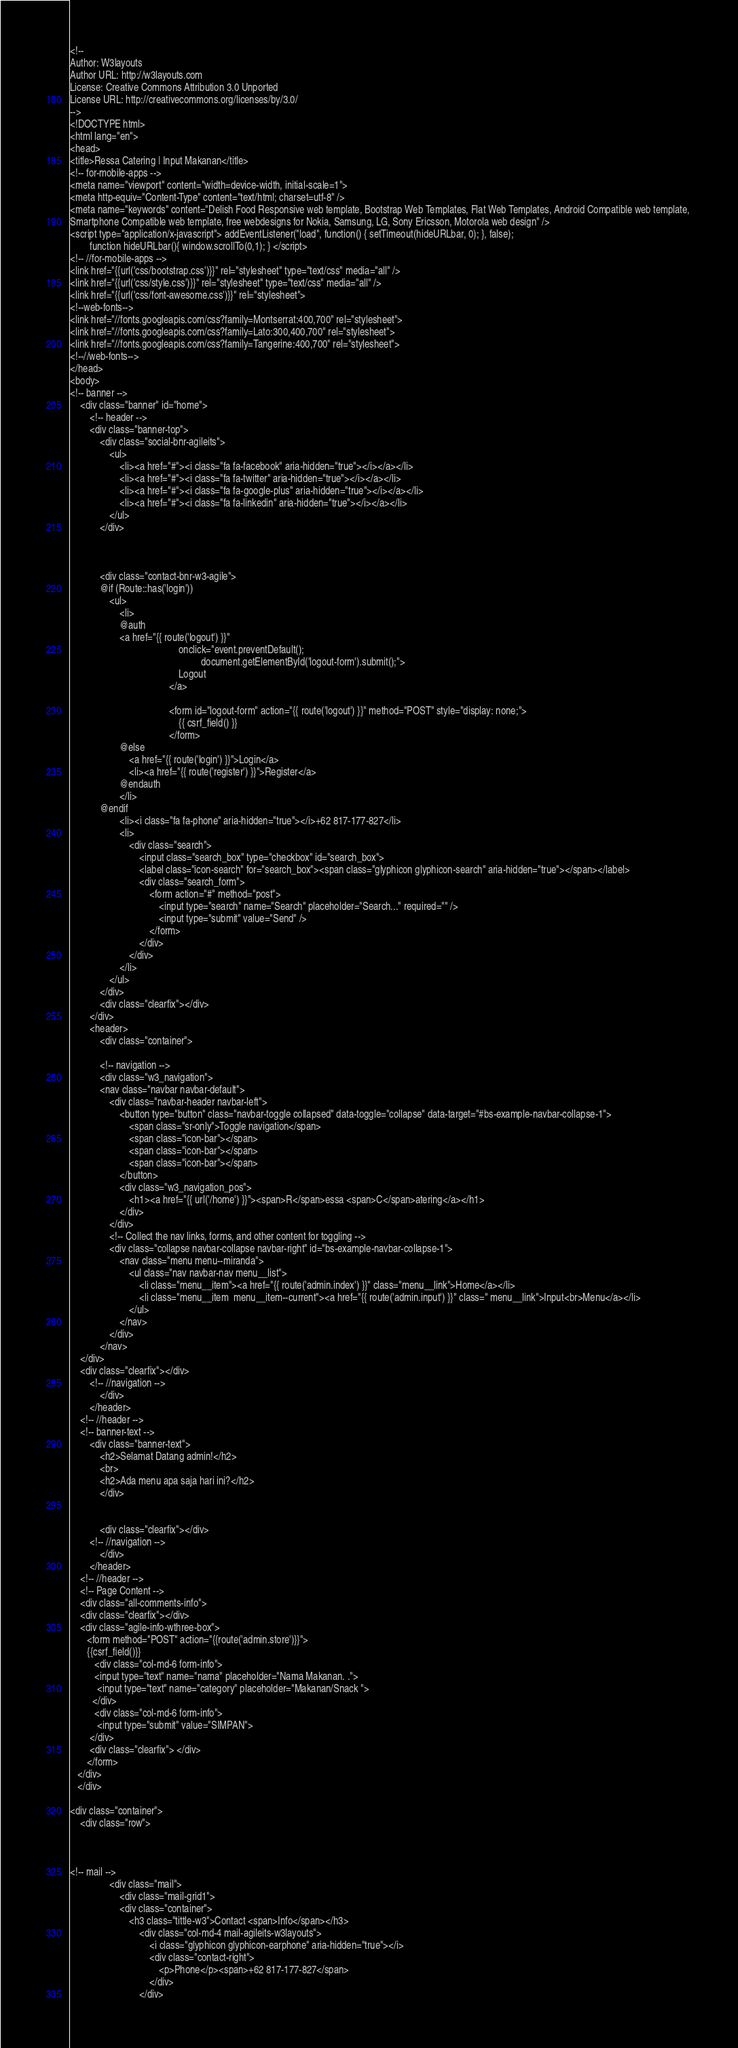Convert code to text. <code><loc_0><loc_0><loc_500><loc_500><_PHP_><!--
Author: W3layouts
Author URL: http://w3layouts.com
License: Creative Commons Attribution 3.0 Unported
License URL: http://creativecommons.org/licenses/by/3.0/
-->
<!DOCTYPE html>
<html lang="en">
<head>
<title>Ressa Catering | Input Makanan</title>
<!-- for-mobile-apps -->
<meta name="viewport" content="width=device-width, initial-scale=1">
<meta http-equiv="Content-Type" content="text/html; charset=utf-8" />
<meta name="keywords" content="Delish Food Responsive web template, Bootstrap Web Templates, Flat Web Templates, Android Compatible web template, 
Smartphone Compatible web template, free webdesigns for Nokia, Samsung, LG, Sony Ericsson, Motorola web design" />
<script type="application/x-javascript"> addEventListener("load", function() { setTimeout(hideURLbar, 0); }, false);
		function hideURLbar(){ window.scrollTo(0,1); } </script>
<!-- //for-mobile-apps -->
<link href="{{url('css/bootstrap.css')}}" rel="stylesheet" type="text/css" media="all" />
<link href="{{url('css/style.css')}}" rel="stylesheet" type="text/css" media="all" />
<link href="{{url('css/font-awesome.css')}}" rel="stylesheet"> 
<!--web-fonts-->
<link href="//fonts.googleapis.com/css?family=Montserrat:400,700" rel="stylesheet">
<link href="//fonts.googleapis.com/css?family=Lato:300,400,700" rel="stylesheet">
<link href="//fonts.googleapis.com/css?family=Tangerine:400,700" rel="stylesheet">
<!--//web-fonts-->
</head>
<body>
<!-- banner -->
	<div class="banner" id="home">
		<!-- header -->
		<div class="banner-top">
			<div class="social-bnr-agileits">
				<ul>
					<li><a href="#"><i class="fa fa-facebook" aria-hidden="true"></i></a></li>
					<li><a href="#"><i class="fa fa-twitter" aria-hidden="true"></i></a></li>
					<li><a href="#"><i class="fa fa-google-plus" aria-hidden="true"></i></a></li>
					<li><a href="#"><i class="fa fa-linkedin" aria-hidden="true"></i></a></li>					
				</ul>
			</div>

			 
			
			<div class="contact-bnr-w3-agile">
			@if (Route::has('login'))
				<ul>
					<li>
					@auth
					<a href="{{ route('logout') }}"
                                            onclick="event.preventDefault();
                                                     document.getElementById('logout-form').submit();">
                                            Logout
                                        </a>

                                        <form id="logout-form" action="{{ route('logout') }}" method="POST" style="display: none;">
                                            {{ csrf_field() }}
                                        </form>
                    @else
                        <a href="{{ route('login') }}">Login</a>
                        <li><a href="{{ route('register') }}">Register</a>
                    @endauth
					</li>
			@endif
					<li><i class="fa fa-phone" aria-hidden="true"></i>+62 817-177-827</li>	
					<li>
						<div class="search">
							<input class="search_box" type="checkbox" id="search_box">
							<label class="icon-search" for="search_box"><span class="glyphicon glyphicon-search" aria-hidden="true"></span></label>
							<div class="search_form">
								<form action="#" method="post">
									<input type="search" name="Search" placeholder="Search..." required="" />
									<input type="submit" value="Send" />
								</form>
							</div>
						</div>
					</li>
				</ul>
			</div>
			<div class="clearfix"></div>
		</div>
		<header>
			<div class="container">

			<!-- navigation -->
			<div class="w3_navigation">
			<nav class="navbar navbar-default">
				<div class="navbar-header navbar-left">
					<button type="button" class="navbar-toggle collapsed" data-toggle="collapse" data-target="#bs-example-navbar-collapse-1">
						<span class="sr-only">Toggle navigation</span>
						<span class="icon-bar"></span>
						<span class="icon-bar"></span>
						<span class="icon-bar"></span>
					</button>
					<div class="w3_navigation_pos">
						<h1><a href="{{ url('/home') }}"><span>R</span>essa <span>C</span>atering</a></h1>
					</div>
				</div>
				<!-- Collect the nav links, forms, and other content for toggling -->
				<div class="collapse navbar-collapse navbar-right" id="bs-example-navbar-collapse-1">
					<nav class="menu menu--miranda">
						<ul class="nav navbar-nav menu__list">
							<li class="menu__item"><a href="{{ route('admin.index') }}" class="menu__link">Home</a></li>
							<li class="menu__item  menu__item--current"><a href="{{ route('admin.input') }}" class=" menu__link">Input<br>Menu</a></li>
						</ul>
					</nav>
				</div>
			</nav>	
	</div>
	<div class="clearfix"></div>
		<!-- //navigation -->
			</div>
		</header>
	<!-- //header -->
	<!-- banner-text -->
		<div class="banner-text"> 
			<h2>Selamat Datang admin!</h2>
			<br>
			<h2>Ada menu apa saja hari ini?</h2>
			</div>
	
	
            <div class="clearfix"></div>
		<!-- //navigation -->
			</div>
		</header>
	<!-- //header -->
	<!-- Page Content -->
	<div class="all-comments-info">
	<div class="clearfix"></div>
	<div class="agile-info-wthree-box">
	   <form method="POST" action="{{route('admin.store')}}">
	   {{csrf_field()}}
		  <div class="col-md-6 form-info">
		  <input type="text" name="nama" placeholder="Nama Makanan. .">
		   <input type="text" name="category" placeholder="Makanan/Snack ">			           					   
		 </div>
		  <div class="col-md-6 form-info">
		   <input type="submit" value="SIMPAN">
		</div>
		<div class="clearfix"> </div>
	   </form>
   </div>
   </div>

<div class="container">
	<div class="row">
		
        
        
<!-- mail -->
				<div class="mail">
					<div class="mail-grid1">
					<div class="container">	
						<h3 class="tittle-w3">Contact <span>Info</span></h3>
							<div class="col-md-4 mail-agileits-w3layouts">
								<i class="glyphicon glyphicon-earphone" aria-hidden="true"></i>
								<div class="contact-right">
									<p>Phone</p><span>+62 817-177-827</span>
								</div>
							</div></code> 